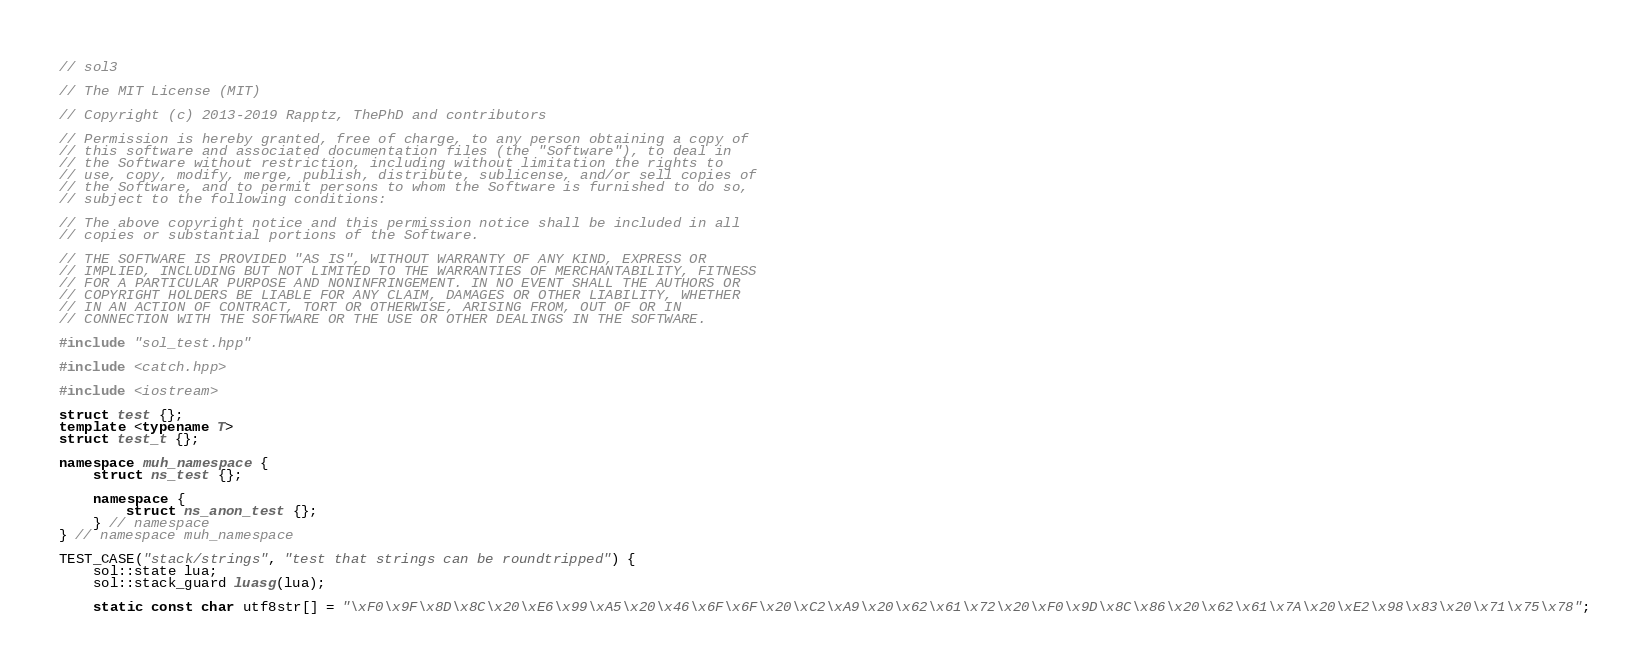<code> <loc_0><loc_0><loc_500><loc_500><_C++_>// sol3 

// The MIT License (MIT)

// Copyright (c) 2013-2019 Rapptz, ThePhD and contributors

// Permission is hereby granted, free of charge, to any person obtaining a copy of
// this software and associated documentation files (the "Software"), to deal in
// the Software without restriction, including without limitation the rights to
// use, copy, modify, merge, publish, distribute, sublicense, and/or sell copies of
// the Software, and to permit persons to whom the Software is furnished to do so,
// subject to the following conditions:

// The above copyright notice and this permission notice shall be included in all
// copies or substantial portions of the Software.

// THE SOFTWARE IS PROVIDED "AS IS", WITHOUT WARRANTY OF ANY KIND, EXPRESS OR
// IMPLIED, INCLUDING BUT NOT LIMITED TO THE WARRANTIES OF MERCHANTABILITY, FITNESS
// FOR A PARTICULAR PURPOSE AND NONINFRINGEMENT. IN NO EVENT SHALL THE AUTHORS OR
// COPYRIGHT HOLDERS BE LIABLE FOR ANY CLAIM, DAMAGES OR OTHER LIABILITY, WHETHER
// IN AN ACTION OF CONTRACT, TORT OR OTHERWISE, ARISING FROM, OUT OF OR IN
// CONNECTION WITH THE SOFTWARE OR THE USE OR OTHER DEALINGS IN THE SOFTWARE.

#include "sol_test.hpp"

#include <catch.hpp>

#include <iostream>

struct test {};
template <typename T>
struct test_t {};

namespace muh_namespace {
	struct ns_test {};

	namespace {
		struct ns_anon_test {};
	} // namespace
} // namespace muh_namespace

TEST_CASE("stack/strings", "test that strings can be roundtripped") {
	sol::state lua;
	sol::stack_guard luasg(lua);

	static const char utf8str[] = "\xF0\x9F\x8D\x8C\x20\xE6\x99\xA5\x20\x46\x6F\x6F\x20\xC2\xA9\x20\x62\x61\x72\x20\xF0\x9D\x8C\x86\x20\x62\x61\x7A\x20\xE2\x98\x83\x20\x71\x75\x78";</code> 